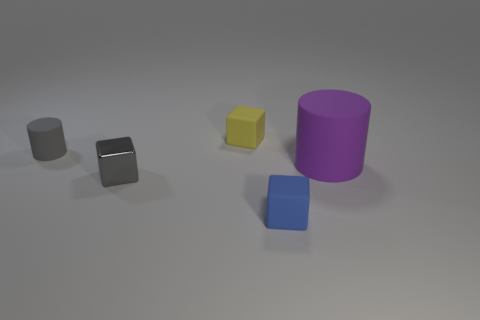What size is the other object that is the same color as the small metal thing? The small metal thing is silver, and there is another object of a similar silver color, which looks like a cube. Its size is comparable to the small metal object; both appear to be of a small size relative to the other objects in the image. 